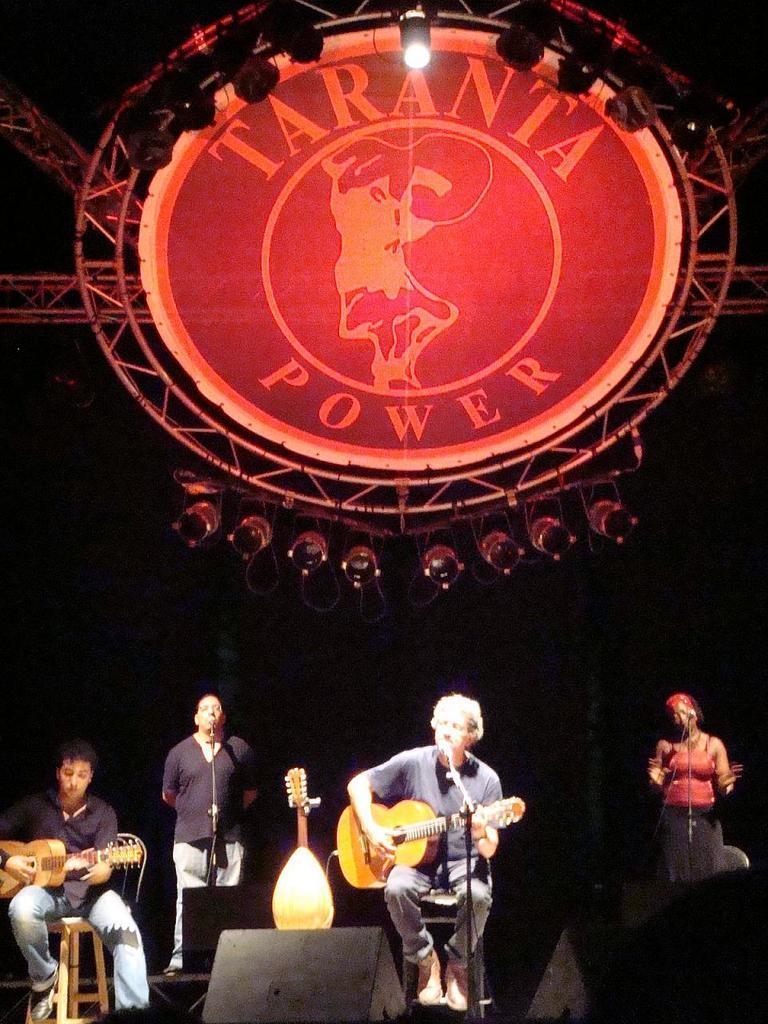Please provide a concise description of this image. In this picture we can see 4 people, 2 are sitting, 2 are standing. Left most person is sitting on chair and holding guitar and seems like playing it and the next person to his left is behind the microphone and the left person to him is also having guitar in his hand, he seems like playing it and at the top most right of the picture we have a lady behind microphone who seems like singing and here we can see the term taranta power, it may be the musical concert name. 